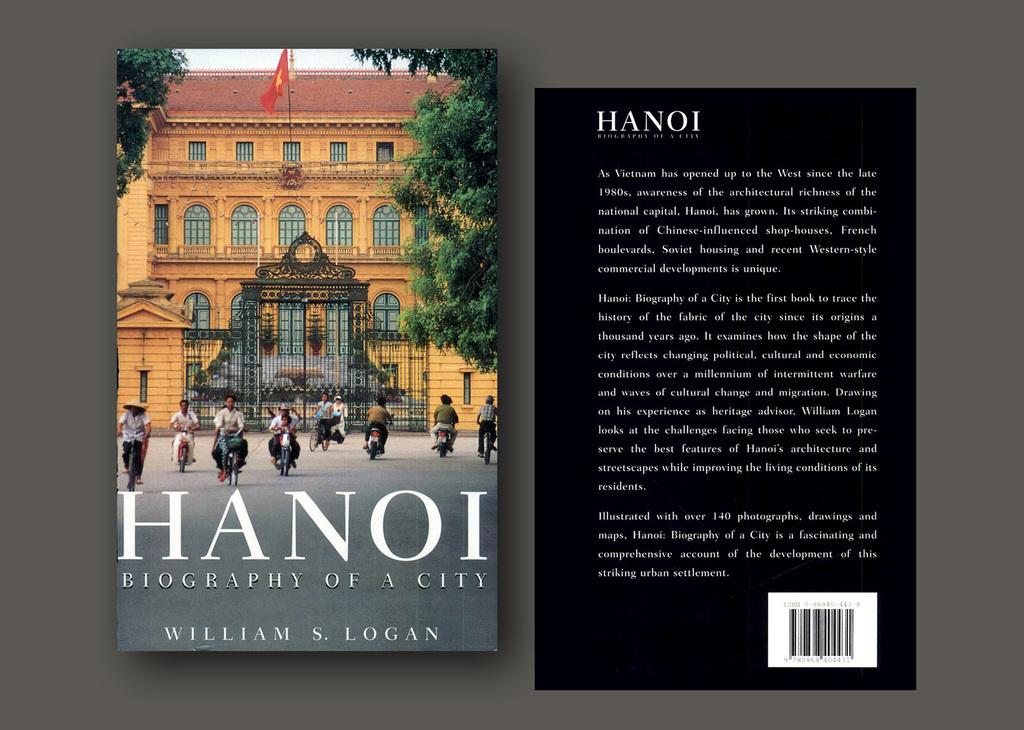<image>
Relay a brief, clear account of the picture shown. A book entitled Biography of a city by william S. Logan 